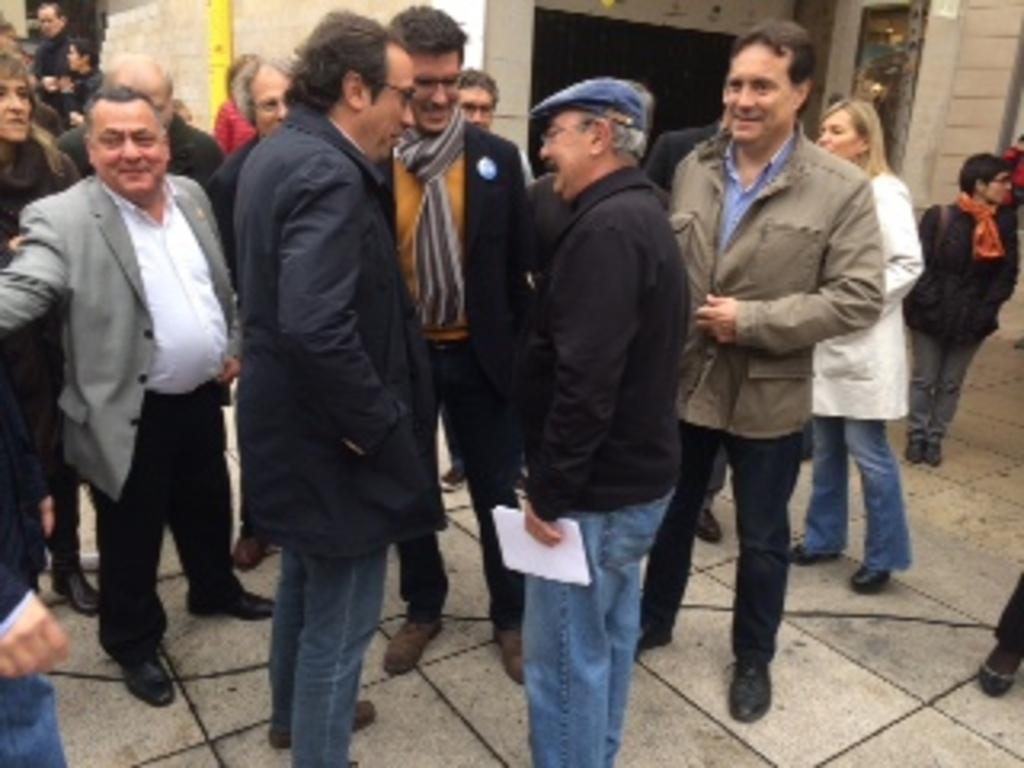How many people are in the image? There is a group of people in the image. What are the people doing in the image? The people are standing on the ground. Can you describe the man in the image? There is a man holding papers in the image. What can be seen in the background of the image? There is a wall in the background of the image. What type of tongue can be seen sticking out of the wall in the image? There is no tongue visible in the image, and the wall does not have any features that resemble a tongue. 